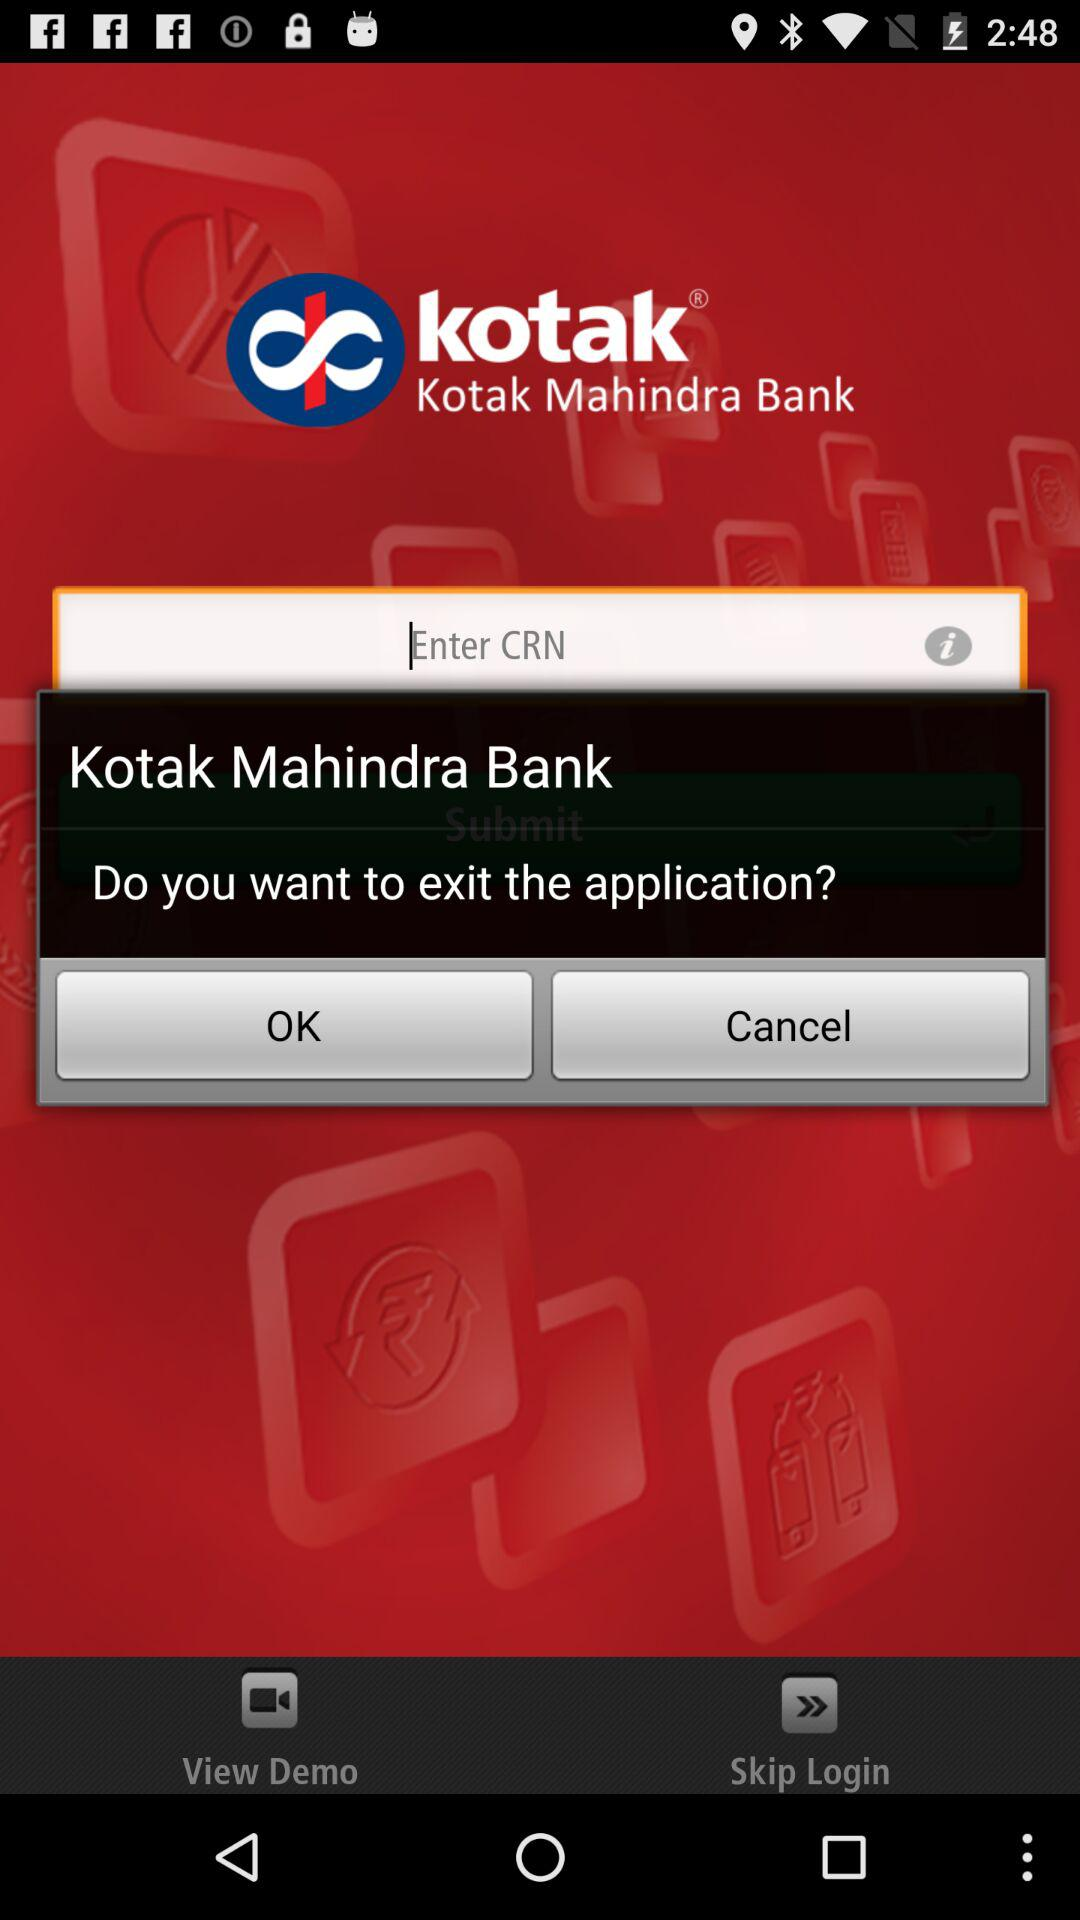What is the name of the application? The name of the application is "Kotak Mahindra Bank". 